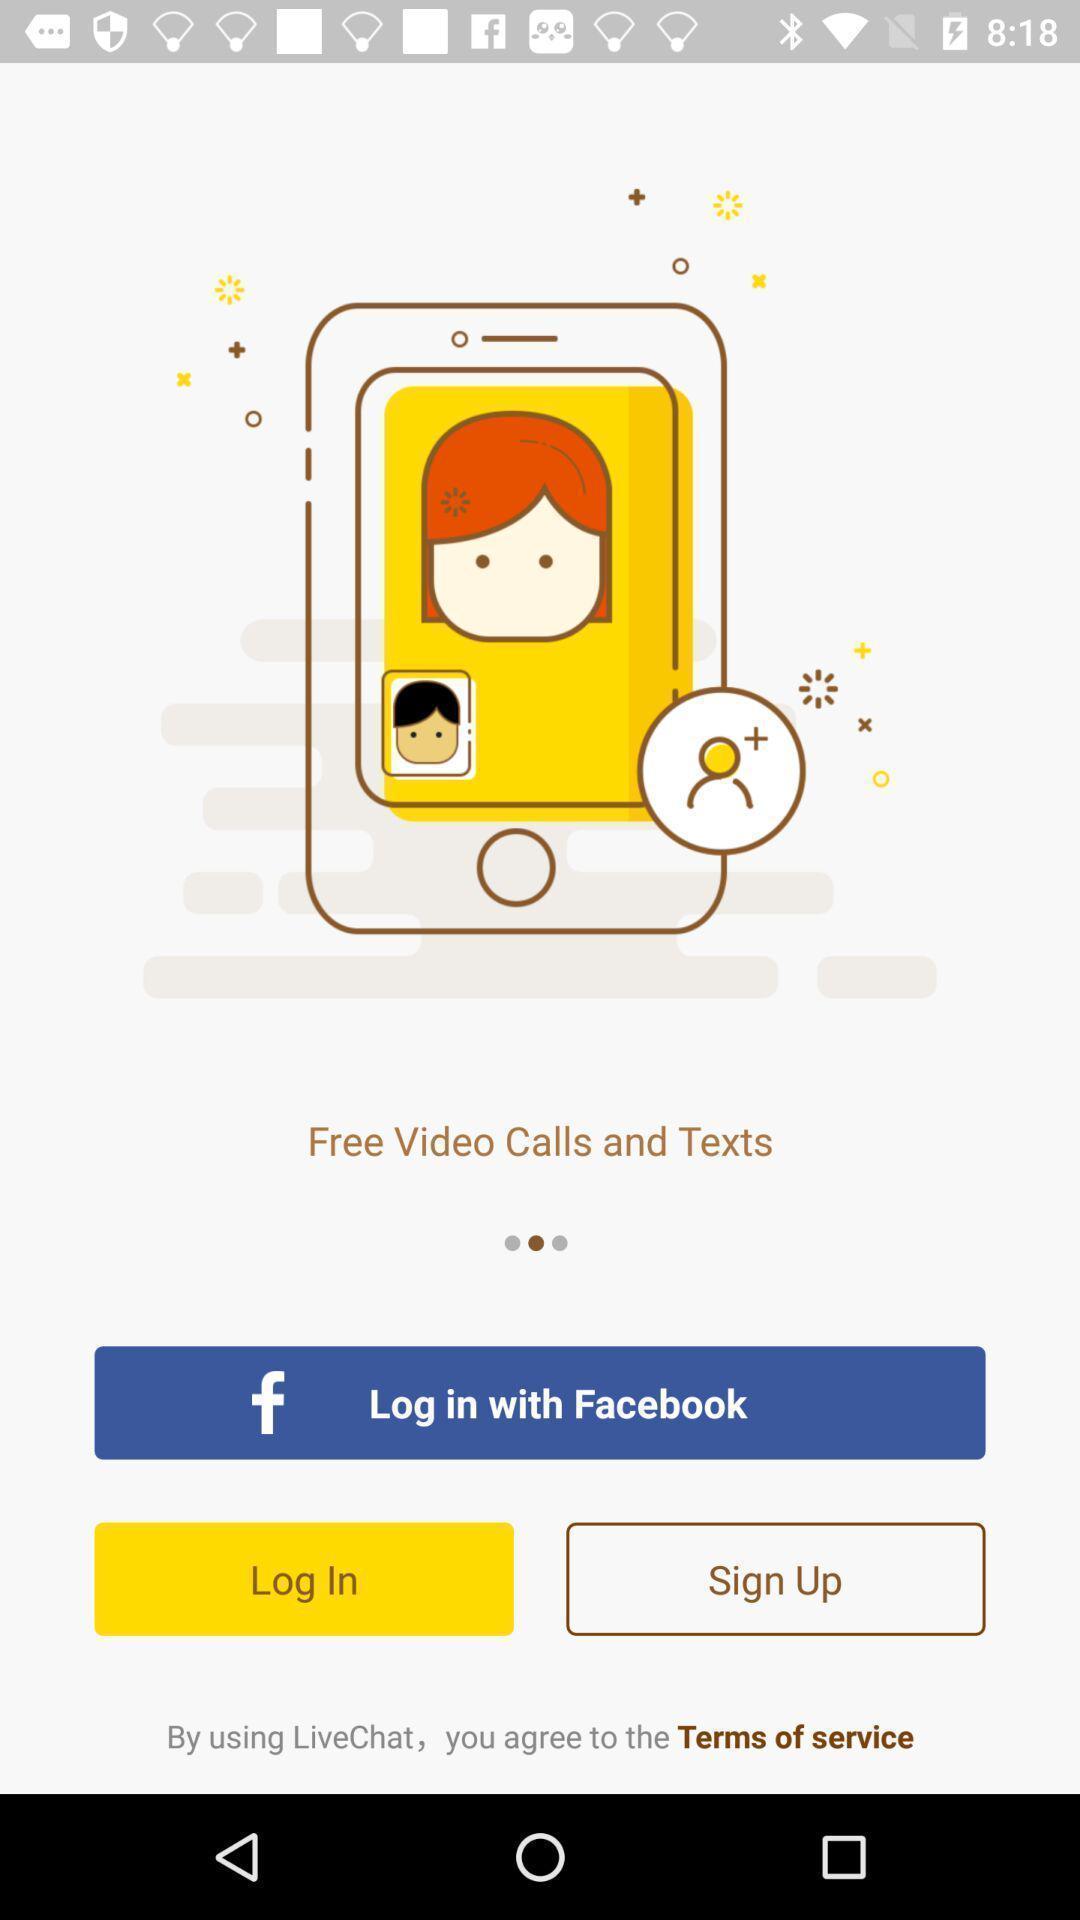Summarize the main components in this picture. Welcome page of a video chat app. 